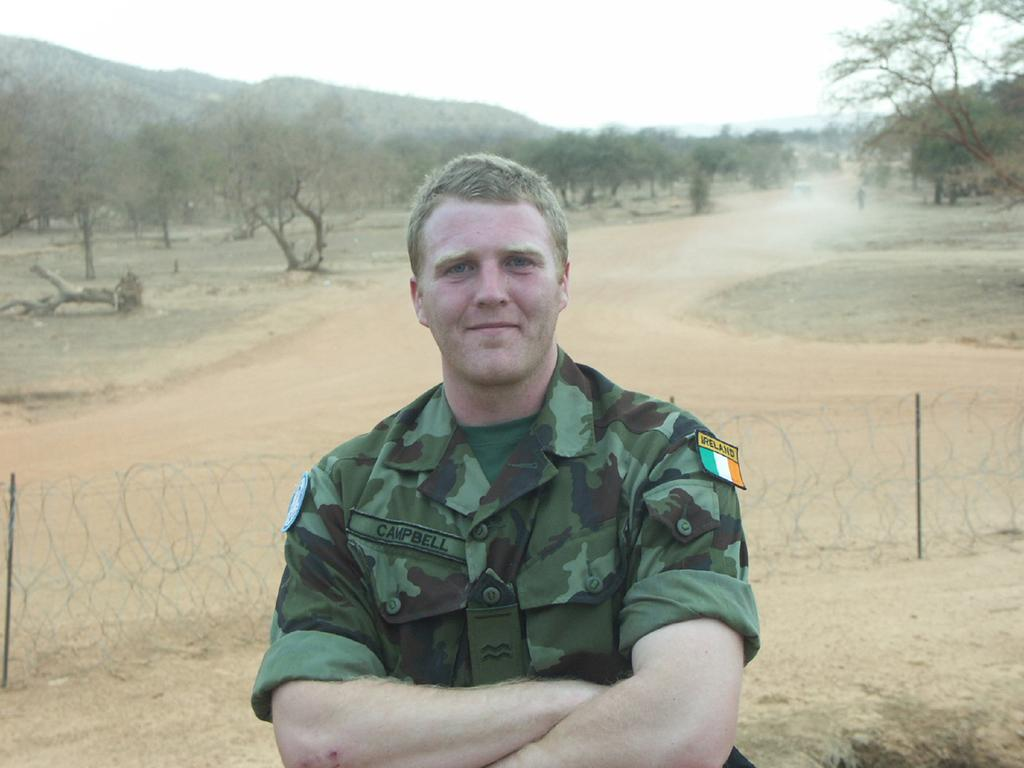Who is the main subject in the image? There is a man in the image. What is the man doing in the image? The man is posing for a camera. What is the man's facial expression in the image? The man is smiling. What can be seen in the background of the image? There are trees and the sky visible in the background of the image. What type of wool is being used to create the man's clothing in the image? There is no information about the man's clothing or the use of wool in the image. 